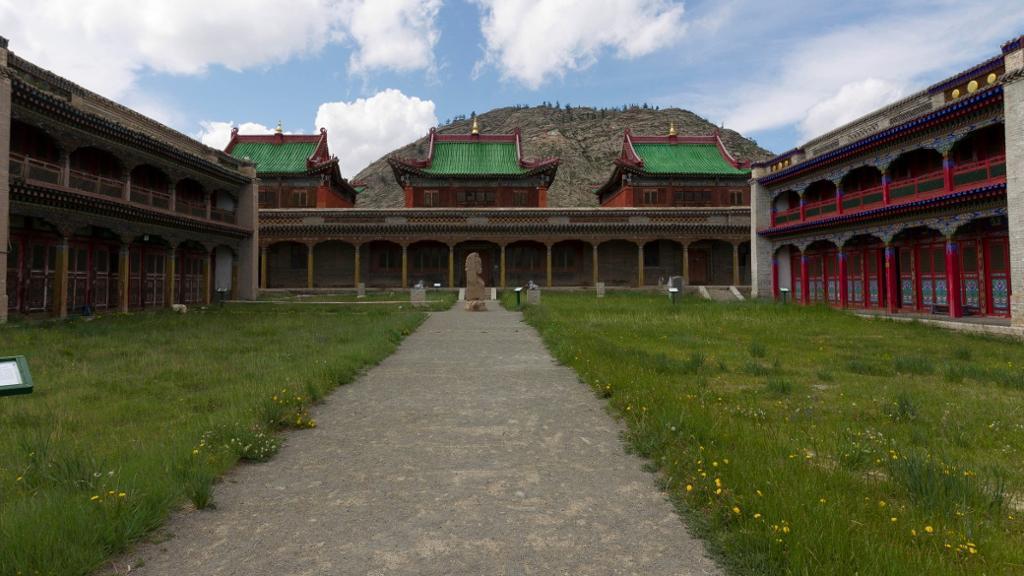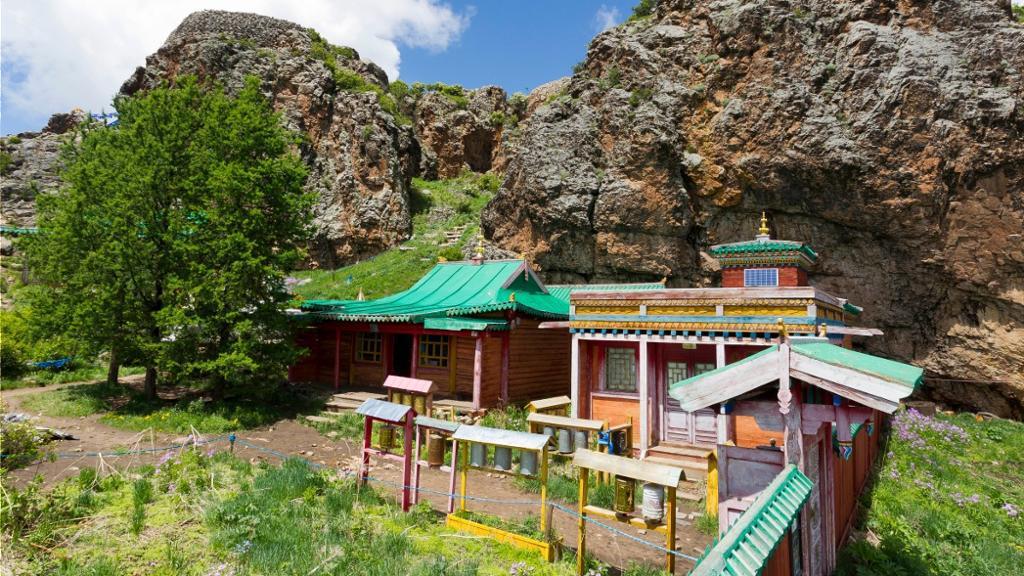The first image is the image on the left, the second image is the image on the right. Given the left and right images, does the statement "An image shows a structure with a yellow trimmed roof and a bulb-like yellow topper." hold true? Answer yes or no. No. 